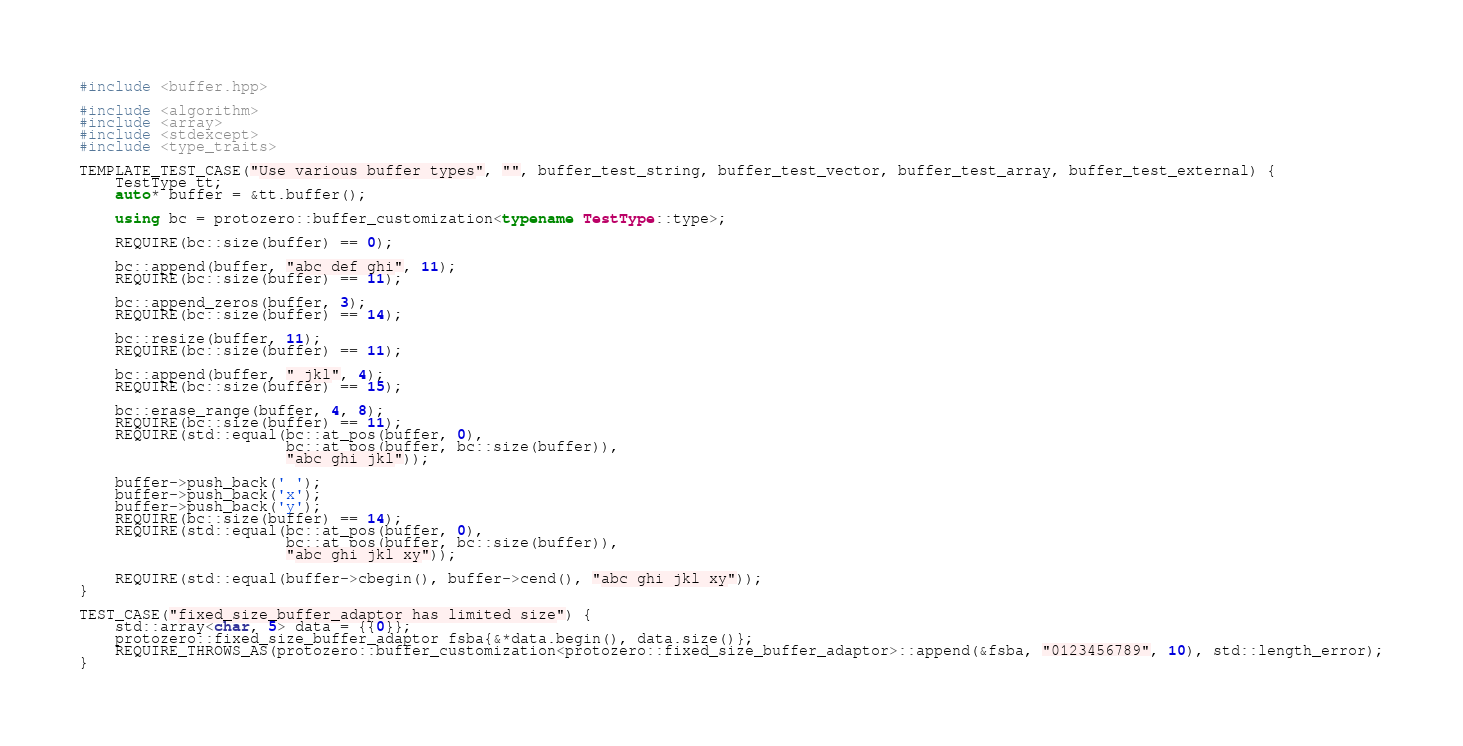Convert code to text. <code><loc_0><loc_0><loc_500><loc_500><_C++_>
#include <buffer.hpp>

#include <algorithm>
#include <array>
#include <stdexcept>
#include <type_traits>

TEMPLATE_TEST_CASE("Use various buffer types", "", buffer_test_string, buffer_test_vector, buffer_test_array, buffer_test_external) {
    TestType tt;
    auto* buffer = &tt.buffer();

    using bc = protozero::buffer_customization<typename TestType::type>;

    REQUIRE(bc::size(buffer) == 0);

    bc::append(buffer, "abc def ghi", 11);
    REQUIRE(bc::size(buffer) == 11);

    bc::append_zeros(buffer, 3);
    REQUIRE(bc::size(buffer) == 14);

    bc::resize(buffer, 11);
    REQUIRE(bc::size(buffer) == 11);

    bc::append(buffer, " jkl", 4);
    REQUIRE(bc::size(buffer) == 15);

    bc::erase_range(buffer, 4, 8);
    REQUIRE(bc::size(buffer) == 11);
    REQUIRE(std::equal(bc::at_pos(buffer, 0),
                       bc::at_pos(buffer, bc::size(buffer)),
                       "abc ghi jkl"));

    buffer->push_back(' ');
    buffer->push_back('x');
    buffer->push_back('y');
    REQUIRE(bc::size(buffer) == 14);
    REQUIRE(std::equal(bc::at_pos(buffer, 0),
                       bc::at_pos(buffer, bc::size(buffer)),
                       "abc ghi jkl xy"));

    REQUIRE(std::equal(buffer->cbegin(), buffer->cend(), "abc ghi jkl xy"));
}

TEST_CASE("fixed_size_buffer_adaptor has limited size") {
    std::array<char, 5> data = {{0}};
    protozero::fixed_size_buffer_adaptor fsba{&*data.begin(), data.size()};
    REQUIRE_THROWS_AS(protozero::buffer_customization<protozero::fixed_size_buffer_adaptor>::append(&fsba, "0123456789", 10), std::length_error);
}
</code> 